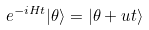Convert formula to latex. <formula><loc_0><loc_0><loc_500><loc_500>e ^ { - i H t } | \theta \rangle = | \theta + u t \rangle</formula> 